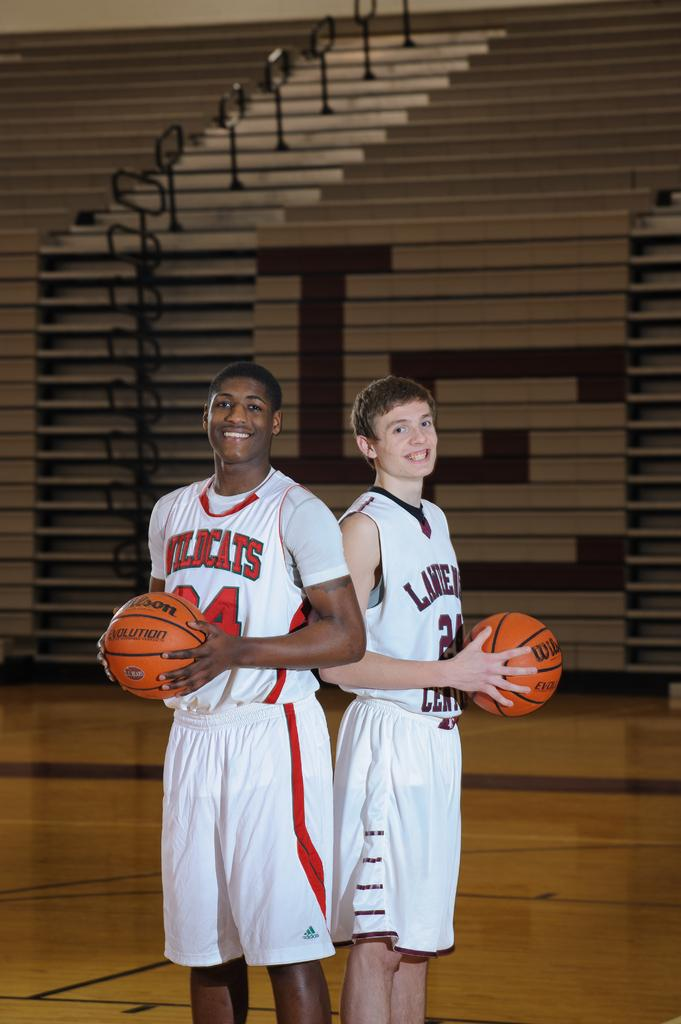Provide a one-sentence caption for the provided image. Wildcats is the name of the team on the jersey of this basketball player. 